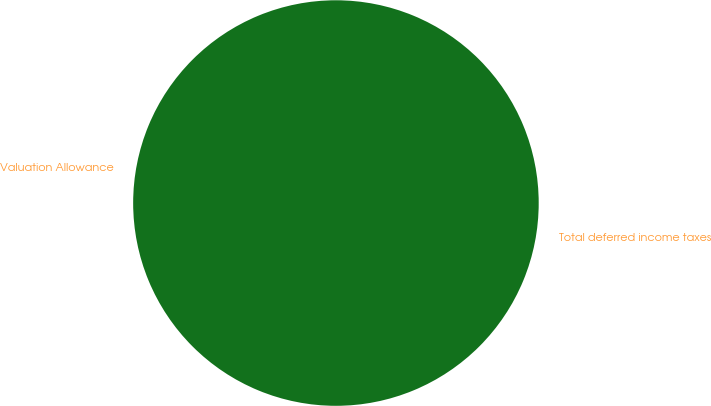Convert chart. <chart><loc_0><loc_0><loc_500><loc_500><pie_chart><fcel>Valuation Allowance<fcel>Total deferred income taxes<nl><fcel>0.0%<fcel>100.0%<nl></chart> 